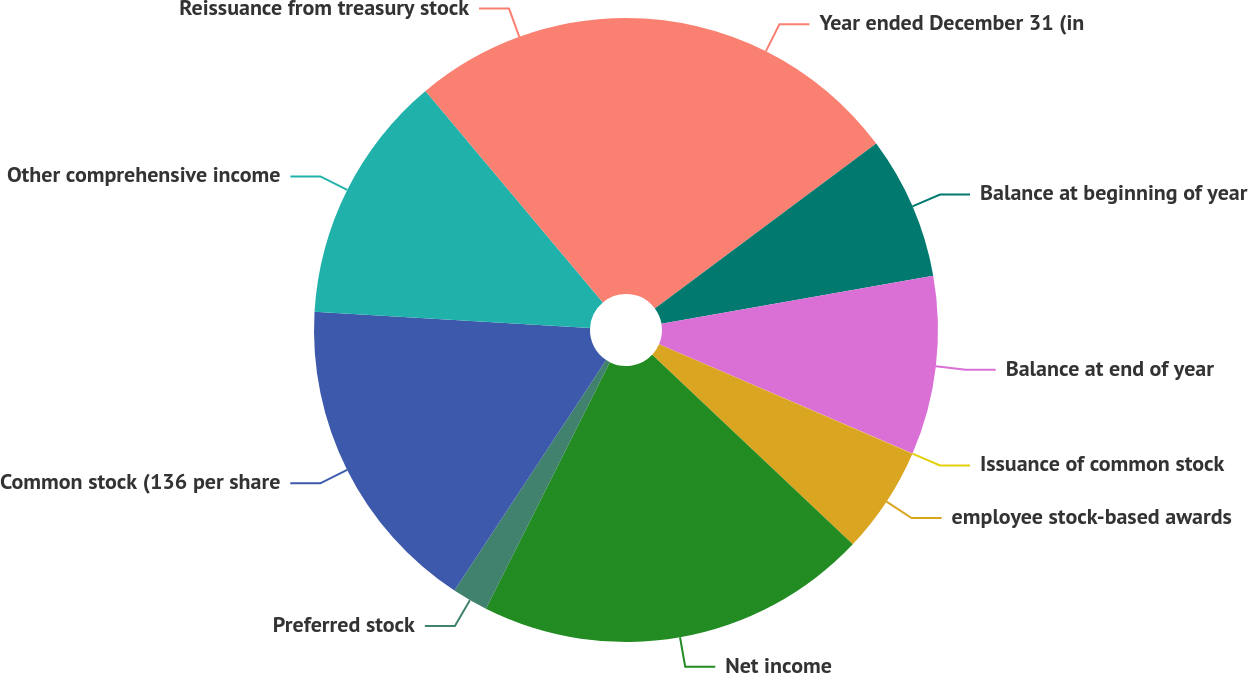Convert chart to OTSL. <chart><loc_0><loc_0><loc_500><loc_500><pie_chart><fcel>Year ended December 31 (in<fcel>Balance at beginning of year<fcel>Balance at end of year<fcel>Issuance of common stock<fcel>employee stock-based awards<fcel>Net income<fcel>Preferred stock<fcel>Common stock (136 per share<fcel>Other comprehensive income<fcel>Reissuance from treasury stock<nl><fcel>14.81%<fcel>7.41%<fcel>9.26%<fcel>0.01%<fcel>5.56%<fcel>20.36%<fcel>1.86%<fcel>16.66%<fcel>12.96%<fcel>11.11%<nl></chart> 